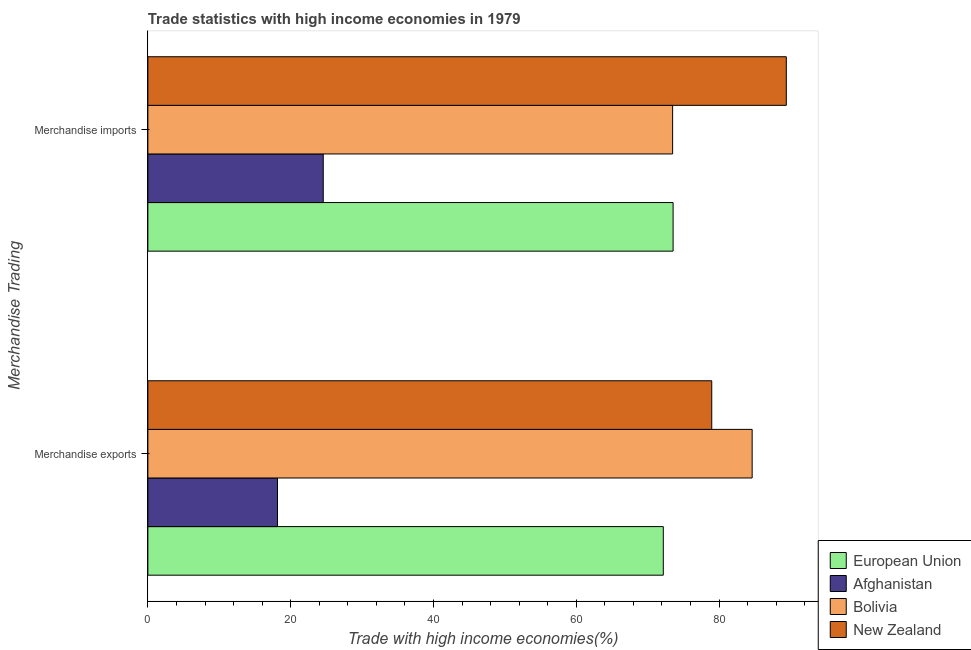How many different coloured bars are there?
Your answer should be very brief. 4. How many groups of bars are there?
Ensure brevity in your answer.  2. Are the number of bars per tick equal to the number of legend labels?
Offer a very short reply. Yes. What is the merchandise imports in European Union?
Your answer should be compact. 73.55. Across all countries, what is the maximum merchandise exports?
Ensure brevity in your answer.  84.63. Across all countries, what is the minimum merchandise exports?
Make the answer very short. 18.15. In which country was the merchandise exports minimum?
Offer a very short reply. Afghanistan. What is the total merchandise exports in the graph?
Provide a succinct answer. 253.93. What is the difference between the merchandise imports in New Zealand and that in Afghanistan?
Give a very brief answer. 64.85. What is the difference between the merchandise exports in Bolivia and the merchandise imports in Afghanistan?
Provide a short and direct response. 60.07. What is the average merchandise imports per country?
Make the answer very short. 65.25. What is the difference between the merchandise exports and merchandise imports in New Zealand?
Your answer should be very brief. -10.44. In how many countries, is the merchandise exports greater than 48 %?
Make the answer very short. 3. What is the ratio of the merchandise exports in European Union to that in New Zealand?
Your answer should be compact. 0.91. Is the merchandise exports in Afghanistan less than that in European Union?
Provide a succinct answer. Yes. In how many countries, is the merchandise exports greater than the average merchandise exports taken over all countries?
Offer a very short reply. 3. What does the 3rd bar from the top in Merchandise imports represents?
Offer a very short reply. Afghanistan. What does the 1st bar from the bottom in Merchandise exports represents?
Provide a short and direct response. European Union. How many countries are there in the graph?
Your answer should be compact. 4. Are the values on the major ticks of X-axis written in scientific E-notation?
Your response must be concise. No. Does the graph contain any zero values?
Offer a very short reply. No. Where does the legend appear in the graph?
Give a very brief answer. Bottom right. How are the legend labels stacked?
Your answer should be very brief. Vertical. What is the title of the graph?
Give a very brief answer. Trade statistics with high income economies in 1979. Does "Turkmenistan" appear as one of the legend labels in the graph?
Keep it short and to the point. No. What is the label or title of the X-axis?
Offer a very short reply. Trade with high income economies(%). What is the label or title of the Y-axis?
Provide a succinct answer. Merchandise Trading. What is the Trade with high income economies(%) in European Union in Merchandise exports?
Keep it short and to the point. 72.18. What is the Trade with high income economies(%) in Afghanistan in Merchandise exports?
Your response must be concise. 18.15. What is the Trade with high income economies(%) of Bolivia in Merchandise exports?
Provide a succinct answer. 84.63. What is the Trade with high income economies(%) in New Zealand in Merchandise exports?
Ensure brevity in your answer.  78.97. What is the Trade with high income economies(%) of European Union in Merchandise imports?
Keep it short and to the point. 73.55. What is the Trade with high income economies(%) in Afghanistan in Merchandise imports?
Provide a short and direct response. 24.56. What is the Trade with high income economies(%) of Bolivia in Merchandise imports?
Provide a succinct answer. 73.49. What is the Trade with high income economies(%) of New Zealand in Merchandise imports?
Keep it short and to the point. 89.41. Across all Merchandise Trading, what is the maximum Trade with high income economies(%) of European Union?
Provide a succinct answer. 73.55. Across all Merchandise Trading, what is the maximum Trade with high income economies(%) of Afghanistan?
Your answer should be compact. 24.56. Across all Merchandise Trading, what is the maximum Trade with high income economies(%) of Bolivia?
Your response must be concise. 84.63. Across all Merchandise Trading, what is the maximum Trade with high income economies(%) of New Zealand?
Your answer should be compact. 89.41. Across all Merchandise Trading, what is the minimum Trade with high income economies(%) of European Union?
Provide a succinct answer. 72.18. Across all Merchandise Trading, what is the minimum Trade with high income economies(%) of Afghanistan?
Provide a succinct answer. 18.15. Across all Merchandise Trading, what is the minimum Trade with high income economies(%) of Bolivia?
Give a very brief answer. 73.49. Across all Merchandise Trading, what is the minimum Trade with high income economies(%) of New Zealand?
Your answer should be very brief. 78.97. What is the total Trade with high income economies(%) in European Union in the graph?
Give a very brief answer. 145.74. What is the total Trade with high income economies(%) in Afghanistan in the graph?
Make the answer very short. 42.71. What is the total Trade with high income economies(%) of Bolivia in the graph?
Provide a short and direct response. 158.12. What is the total Trade with high income economies(%) in New Zealand in the graph?
Your answer should be very brief. 168.38. What is the difference between the Trade with high income economies(%) of European Union in Merchandise exports and that in Merchandise imports?
Your response must be concise. -1.37. What is the difference between the Trade with high income economies(%) of Afghanistan in Merchandise exports and that in Merchandise imports?
Offer a very short reply. -6.41. What is the difference between the Trade with high income economies(%) of Bolivia in Merchandise exports and that in Merchandise imports?
Offer a terse response. 11.14. What is the difference between the Trade with high income economies(%) in New Zealand in Merchandise exports and that in Merchandise imports?
Keep it short and to the point. -10.44. What is the difference between the Trade with high income economies(%) in European Union in Merchandise exports and the Trade with high income economies(%) in Afghanistan in Merchandise imports?
Your answer should be compact. 47.62. What is the difference between the Trade with high income economies(%) of European Union in Merchandise exports and the Trade with high income economies(%) of Bolivia in Merchandise imports?
Offer a very short reply. -1.31. What is the difference between the Trade with high income economies(%) in European Union in Merchandise exports and the Trade with high income economies(%) in New Zealand in Merchandise imports?
Offer a very short reply. -17.23. What is the difference between the Trade with high income economies(%) of Afghanistan in Merchandise exports and the Trade with high income economies(%) of Bolivia in Merchandise imports?
Keep it short and to the point. -55.34. What is the difference between the Trade with high income economies(%) in Afghanistan in Merchandise exports and the Trade with high income economies(%) in New Zealand in Merchandise imports?
Offer a terse response. -71.26. What is the difference between the Trade with high income economies(%) of Bolivia in Merchandise exports and the Trade with high income economies(%) of New Zealand in Merchandise imports?
Provide a short and direct response. -4.78. What is the average Trade with high income economies(%) of European Union per Merchandise Trading?
Keep it short and to the point. 72.87. What is the average Trade with high income economies(%) of Afghanistan per Merchandise Trading?
Your answer should be very brief. 21.36. What is the average Trade with high income economies(%) of Bolivia per Merchandise Trading?
Your answer should be very brief. 79.06. What is the average Trade with high income economies(%) in New Zealand per Merchandise Trading?
Offer a very short reply. 84.19. What is the difference between the Trade with high income economies(%) in European Union and Trade with high income economies(%) in Afghanistan in Merchandise exports?
Your answer should be compact. 54.03. What is the difference between the Trade with high income economies(%) of European Union and Trade with high income economies(%) of Bolivia in Merchandise exports?
Provide a succinct answer. -12.44. What is the difference between the Trade with high income economies(%) of European Union and Trade with high income economies(%) of New Zealand in Merchandise exports?
Make the answer very short. -6.79. What is the difference between the Trade with high income economies(%) in Afghanistan and Trade with high income economies(%) in Bolivia in Merchandise exports?
Provide a short and direct response. -66.47. What is the difference between the Trade with high income economies(%) in Afghanistan and Trade with high income economies(%) in New Zealand in Merchandise exports?
Offer a very short reply. -60.82. What is the difference between the Trade with high income economies(%) of Bolivia and Trade with high income economies(%) of New Zealand in Merchandise exports?
Provide a succinct answer. 5.66. What is the difference between the Trade with high income economies(%) of European Union and Trade with high income economies(%) of Afghanistan in Merchandise imports?
Offer a very short reply. 48.99. What is the difference between the Trade with high income economies(%) of European Union and Trade with high income economies(%) of Bolivia in Merchandise imports?
Provide a succinct answer. 0.07. What is the difference between the Trade with high income economies(%) of European Union and Trade with high income economies(%) of New Zealand in Merchandise imports?
Your response must be concise. -15.86. What is the difference between the Trade with high income economies(%) of Afghanistan and Trade with high income economies(%) of Bolivia in Merchandise imports?
Ensure brevity in your answer.  -48.93. What is the difference between the Trade with high income economies(%) in Afghanistan and Trade with high income economies(%) in New Zealand in Merchandise imports?
Offer a terse response. -64.85. What is the difference between the Trade with high income economies(%) of Bolivia and Trade with high income economies(%) of New Zealand in Merchandise imports?
Your answer should be very brief. -15.92. What is the ratio of the Trade with high income economies(%) of European Union in Merchandise exports to that in Merchandise imports?
Your answer should be compact. 0.98. What is the ratio of the Trade with high income economies(%) in Afghanistan in Merchandise exports to that in Merchandise imports?
Provide a succinct answer. 0.74. What is the ratio of the Trade with high income economies(%) of Bolivia in Merchandise exports to that in Merchandise imports?
Your answer should be compact. 1.15. What is the ratio of the Trade with high income economies(%) in New Zealand in Merchandise exports to that in Merchandise imports?
Your response must be concise. 0.88. What is the difference between the highest and the second highest Trade with high income economies(%) of European Union?
Provide a succinct answer. 1.37. What is the difference between the highest and the second highest Trade with high income economies(%) in Afghanistan?
Give a very brief answer. 6.41. What is the difference between the highest and the second highest Trade with high income economies(%) of Bolivia?
Offer a terse response. 11.14. What is the difference between the highest and the second highest Trade with high income economies(%) of New Zealand?
Provide a short and direct response. 10.44. What is the difference between the highest and the lowest Trade with high income economies(%) of European Union?
Your response must be concise. 1.37. What is the difference between the highest and the lowest Trade with high income economies(%) in Afghanistan?
Ensure brevity in your answer.  6.41. What is the difference between the highest and the lowest Trade with high income economies(%) of Bolivia?
Your response must be concise. 11.14. What is the difference between the highest and the lowest Trade with high income economies(%) of New Zealand?
Offer a terse response. 10.44. 